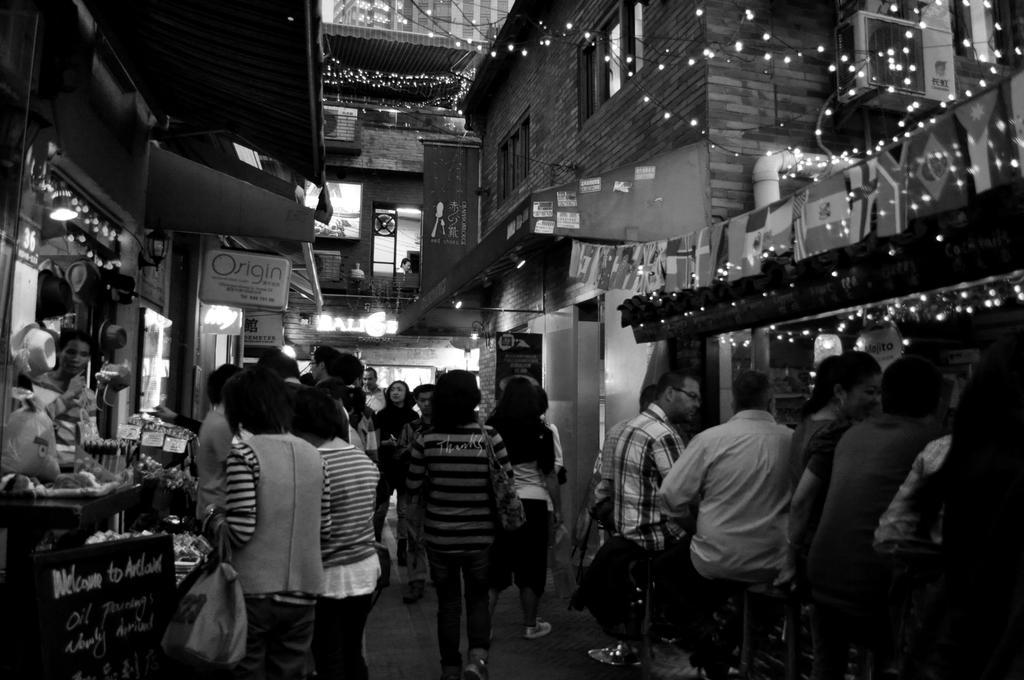How would you summarize this image in a sentence or two? This is a black and white pic. We can see few persons are sitting on the chairs and standing on road. In the background we can see decorative lights,buildings,windows,pipe,AC's,hoardings,stores and objects. 